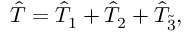Convert formula to latex. <formula><loc_0><loc_0><loc_500><loc_500>\hat { T } = \hat { T } _ { 1 } + \hat { T } _ { 2 } + \hat { T } _ { \tilde { 3 } } ,</formula> 